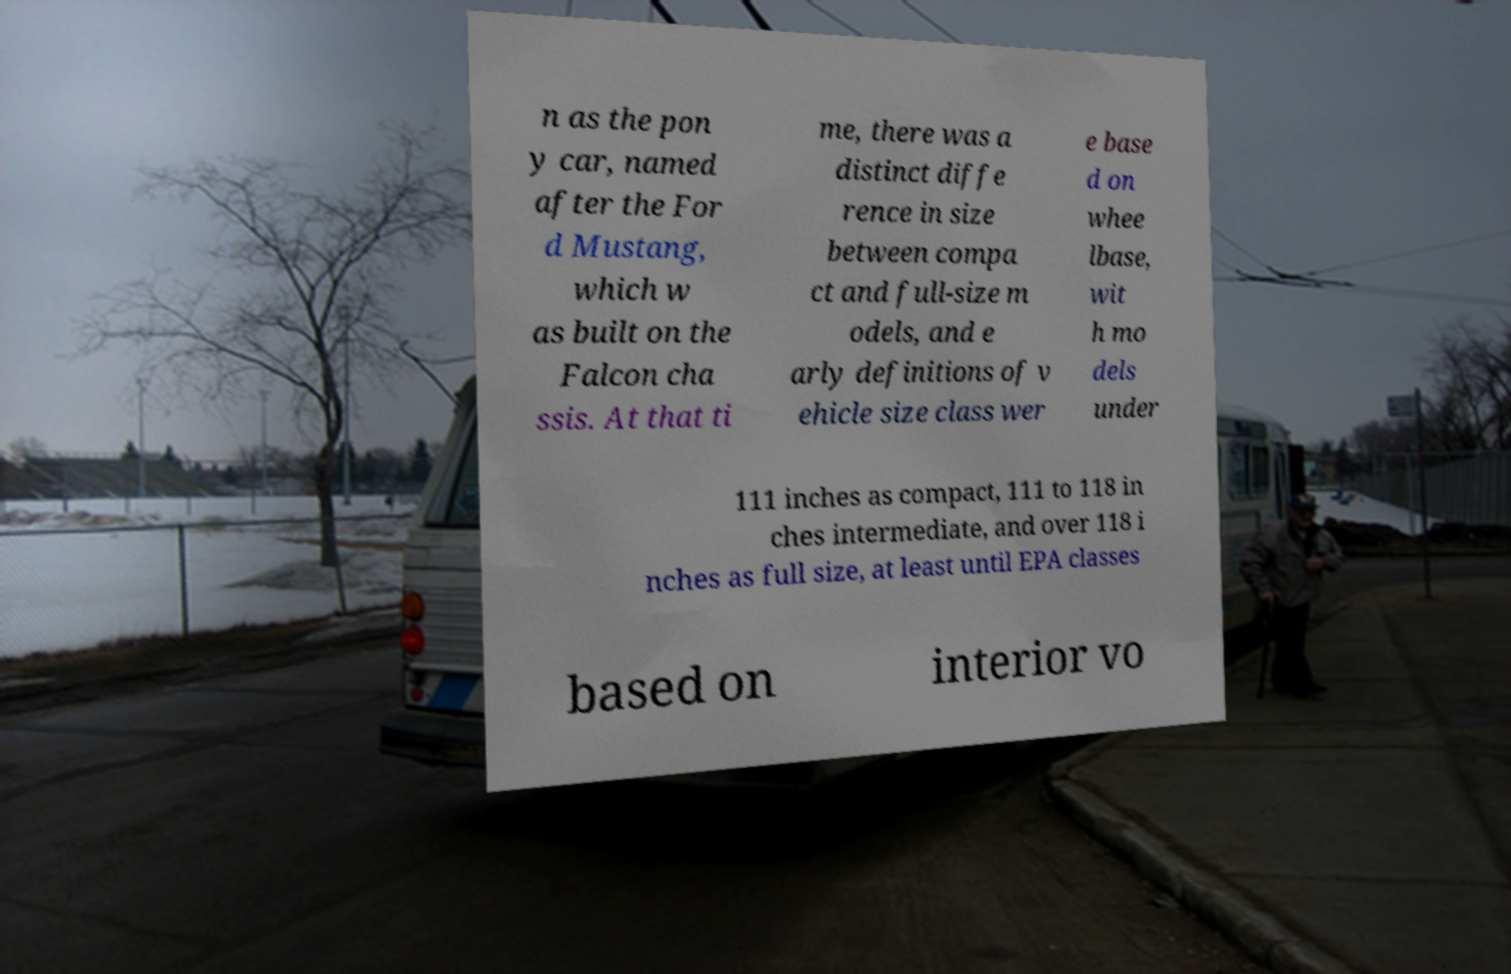I need the written content from this picture converted into text. Can you do that? n as the pon y car, named after the For d Mustang, which w as built on the Falcon cha ssis. At that ti me, there was a distinct diffe rence in size between compa ct and full-size m odels, and e arly definitions of v ehicle size class wer e base d on whee lbase, wit h mo dels under 111 inches as compact, 111 to 118 in ches intermediate, and over 118 i nches as full size, at least until EPA classes based on interior vo 